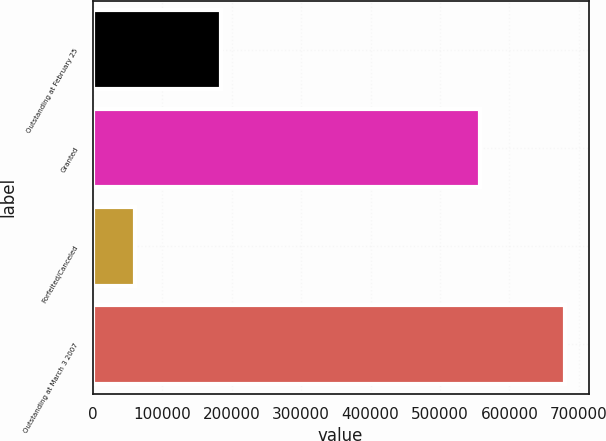Convert chart. <chart><loc_0><loc_0><loc_500><loc_500><bar_chart><fcel>Outstanding at February 25<fcel>Granted<fcel>Forfeited/Canceled<fcel>Outstanding at March 3 2007<nl><fcel>184000<fcel>557000<fcel>61000<fcel>680000<nl></chart> 